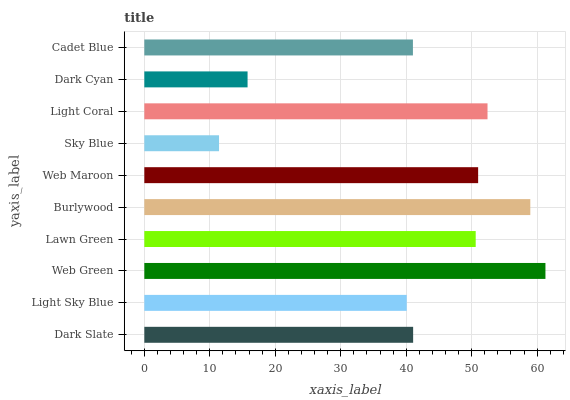Is Sky Blue the minimum?
Answer yes or no. Yes. Is Web Green the maximum?
Answer yes or no. Yes. Is Light Sky Blue the minimum?
Answer yes or no. No. Is Light Sky Blue the maximum?
Answer yes or no. No. Is Dark Slate greater than Light Sky Blue?
Answer yes or no. Yes. Is Light Sky Blue less than Dark Slate?
Answer yes or no. Yes. Is Light Sky Blue greater than Dark Slate?
Answer yes or no. No. Is Dark Slate less than Light Sky Blue?
Answer yes or no. No. Is Lawn Green the high median?
Answer yes or no. Yes. Is Dark Slate the low median?
Answer yes or no. Yes. Is Light Coral the high median?
Answer yes or no. No. Is Sky Blue the low median?
Answer yes or no. No. 